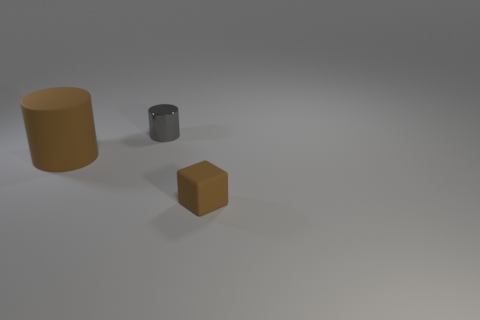Could you approximate the relative sizes of these objects? While exact measurements are challenging without a reference, I can provide a relative comparison. The large cylinder seems to be the tallest object, with a height approximately twice that of the smaller cylinder. The cube's dimensions appear consistent on all sides, thus characterizing it as a standard cube, and it seems to be slightly smaller in scale compared to the diameter of the small cylinder. 